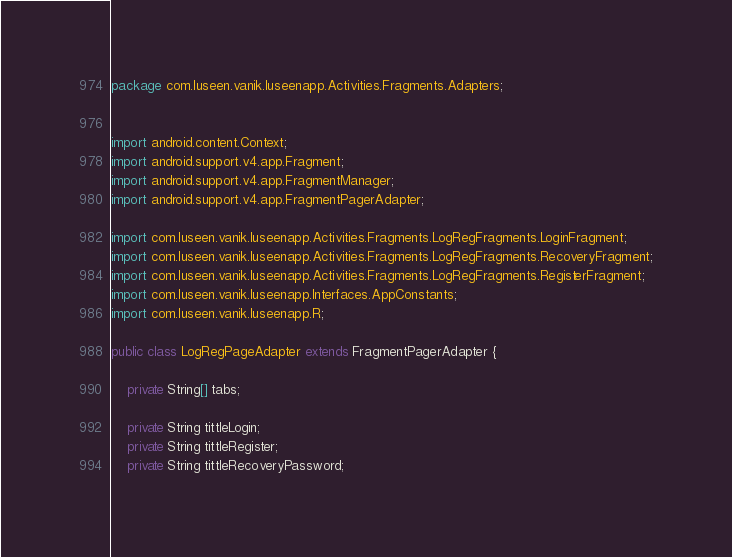Convert code to text. <code><loc_0><loc_0><loc_500><loc_500><_Java_>package com.luseen.vanik.luseenapp.Activities.Fragments.Adapters;


import android.content.Context;
import android.support.v4.app.Fragment;
import android.support.v4.app.FragmentManager;
import android.support.v4.app.FragmentPagerAdapter;

import com.luseen.vanik.luseenapp.Activities.Fragments.LogRegFragments.LoginFragment;
import com.luseen.vanik.luseenapp.Activities.Fragments.LogRegFragments.RecoveryFragment;
import com.luseen.vanik.luseenapp.Activities.Fragments.LogRegFragments.RegisterFragment;
import com.luseen.vanik.luseenapp.Interfaces.AppConstants;
import com.luseen.vanik.luseenapp.R;

public class LogRegPageAdapter extends FragmentPagerAdapter {

    private String[] tabs;

    private String tittleLogin;
    private String tittleRegister;
    private String tittleRecoveryPassword;
</code> 